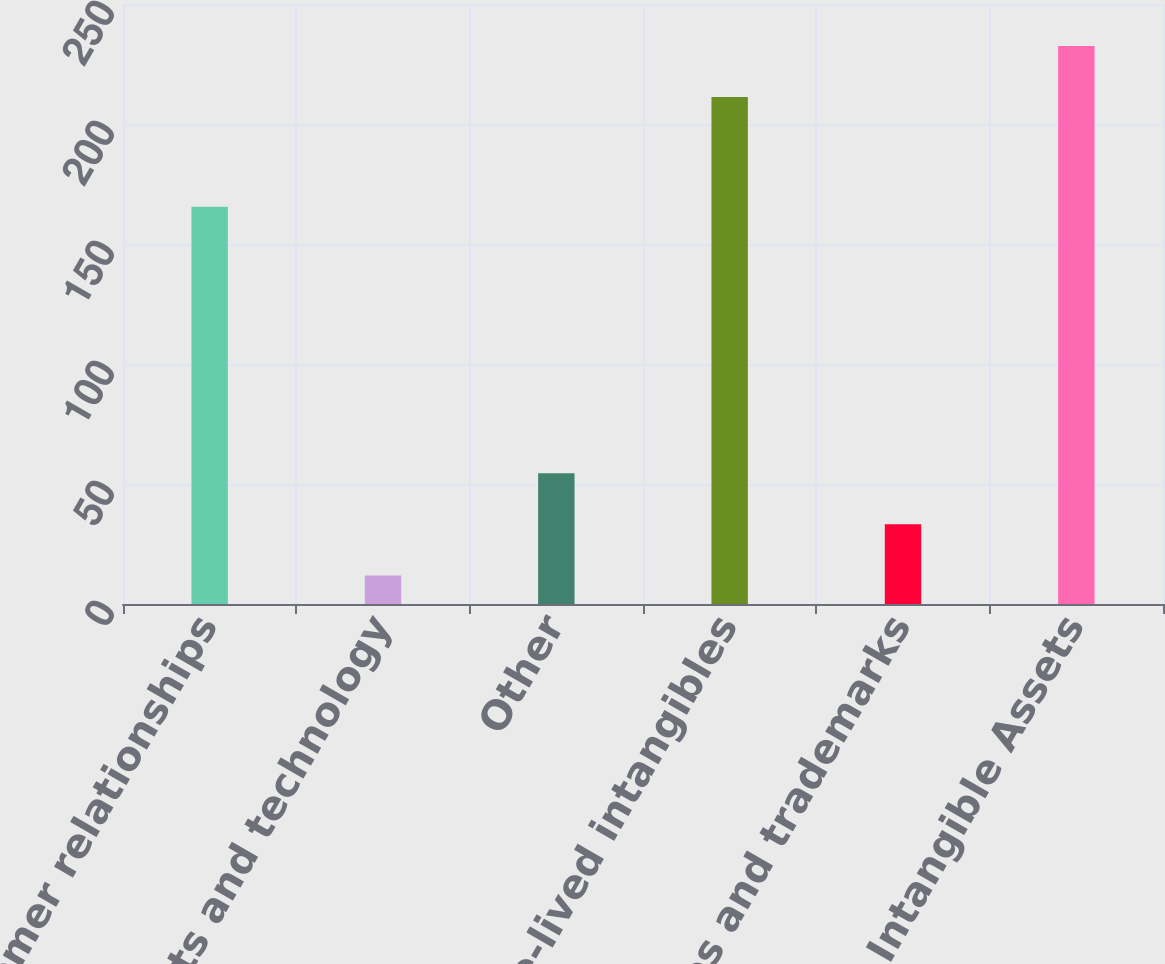Convert chart to OTSL. <chart><loc_0><loc_0><loc_500><loc_500><bar_chart><fcel>Customer relationships<fcel>Patents and technology<fcel>Other<fcel>Total finite-lived intangibles<fcel>Trade names and trademarks<fcel>Total Intangible Assets<nl><fcel>165.5<fcel>11.9<fcel>54.48<fcel>211.2<fcel>33.19<fcel>232.49<nl></chart> 